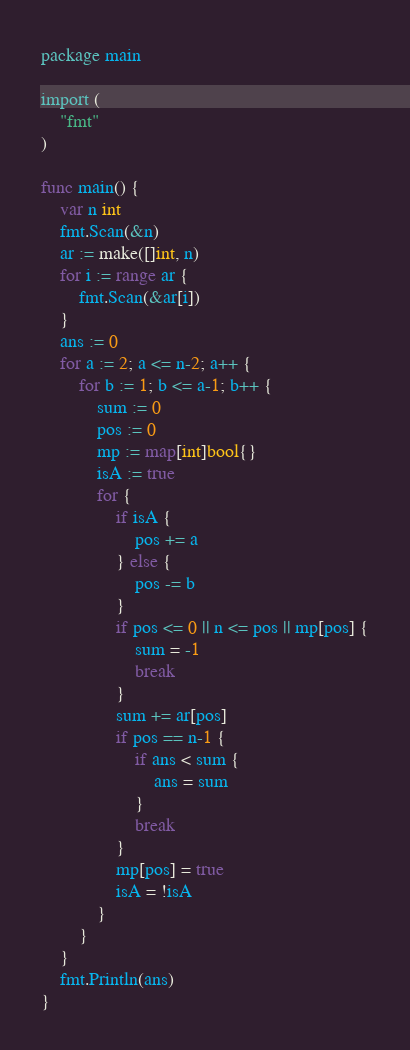Convert code to text. <code><loc_0><loc_0><loc_500><loc_500><_Go_>package main

import (
	"fmt"
)

func main() {
	var n int
	fmt.Scan(&n)
	ar := make([]int, n)
	for i := range ar {
		fmt.Scan(&ar[i])
	}
	ans := 0
	for a := 2; a <= n-2; a++ {
		for b := 1; b <= a-1; b++ {
			sum := 0
			pos := 0
			mp := map[int]bool{}
			isA := true
			for {
				if isA {
					pos += a
				} else {
					pos -= b
				}
				if pos <= 0 || n <= pos || mp[pos] {
					sum = -1
					break
				}
				sum += ar[pos]
				if pos == n-1 {
					if ans < sum {
						ans = sum
					}
					break
				}
				mp[pos] = true
				isA = !isA
			}
		}
	}
	fmt.Println(ans)
}
</code> 